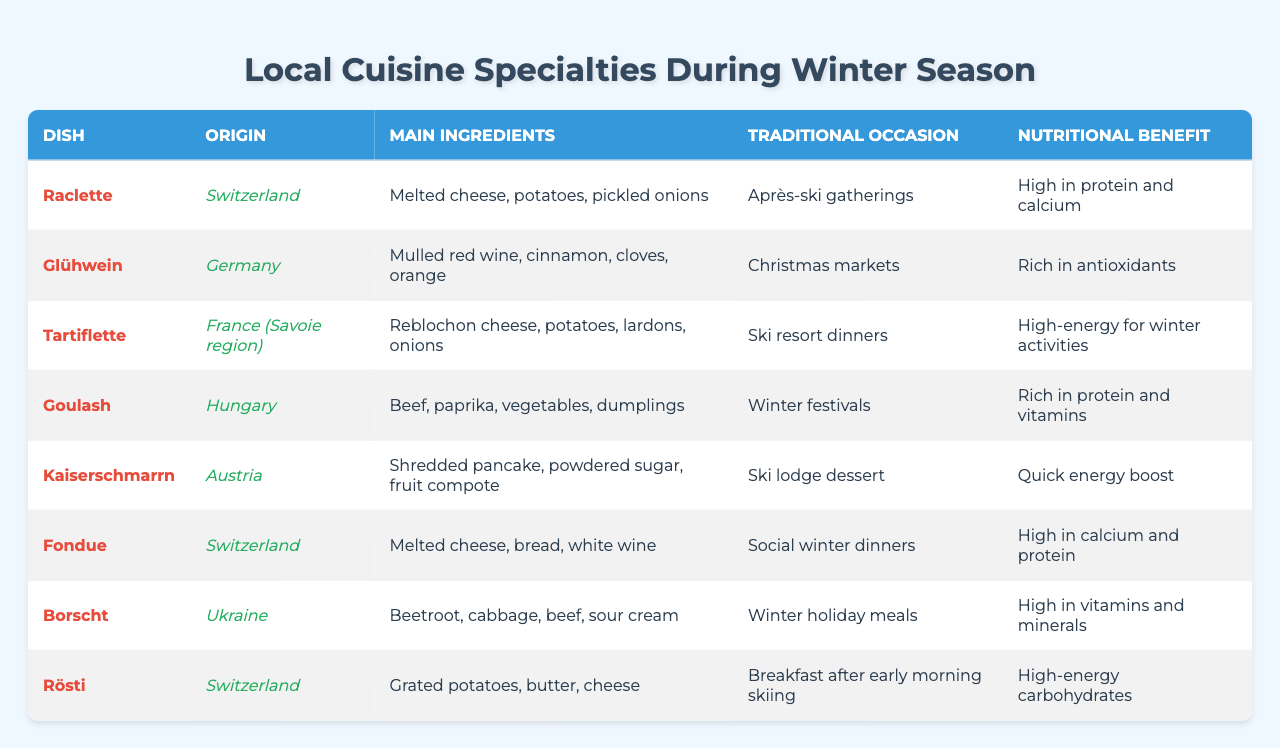What is the origin of Raclette? The table lists Raclette under the "Dish" column, and its corresponding "Origin" is provided. It states that Raclette originates from Switzerland.
Answer: Switzerland What are the main ingredients in Tartiflette? By looking at the "Main Ingredients" column for the dish Tartiflette, we can see that it includes Reblochon cheese, potatoes, lardons, and onions.
Answer: Reblochon cheese, potatoes, lardons, onions Which dish is traditionally served during Christmas markets? The table indicates the traditional occasion for each dish. For Glühwein, it mentions Christmas markets.
Answer: Glühwein How many dishes in the table originate from Switzerland? The table lists Raclette, Fondue, and Rösti as the dishes originating from Switzerland, making it 3 dishes in total.
Answer: 3 Is Goulash considered high in protein? According to the "Nutritional Benefit" column, Goulash is described as rich in protein and vitamins, meaning it is indeed high in protein.
Answer: Yes Which dish provides a quick energy boost? The table identifies Kaiserschmarrn as having a nutritional benefit of offering a quick energy boost, as noted in the "Nutritional Benefit" column.
Answer: Kaiserschmarrn What is the most common origin for the dishes listed? By reviewing the origins of each dish, Switzerland appears most frequently with 3 dishes. Thus, it is the common origin for these cuisines.
Answer: Switzerland Among the dishes, which has the highest calcium content? Fondue and Raclette both are noted for being high in calcium, but since both are categorized under a similar benefit, we consider them equally high in calcium.
Answer: Fondue and Raclette What occasion does Borscht typically accompany? The table states Borscht is traditionally served during winter holiday meals.
Answer: Winter holiday meals What is the primary ingredient in Glühwein? Glühwein's main ingredient as per the respective column is identified as mulled red wine, along with cinnamon, cloves, and orange.
Answer: Mulled red wine How many dishes are designed for social gatherings or celebrations? Looking through the traditional occasions listed, we find definitions pointing to après-ski gatherings, Christmas markets, winter festivals, ski resort dinners, and social winter dinners, which totals 5 dishes.
Answer: 5 